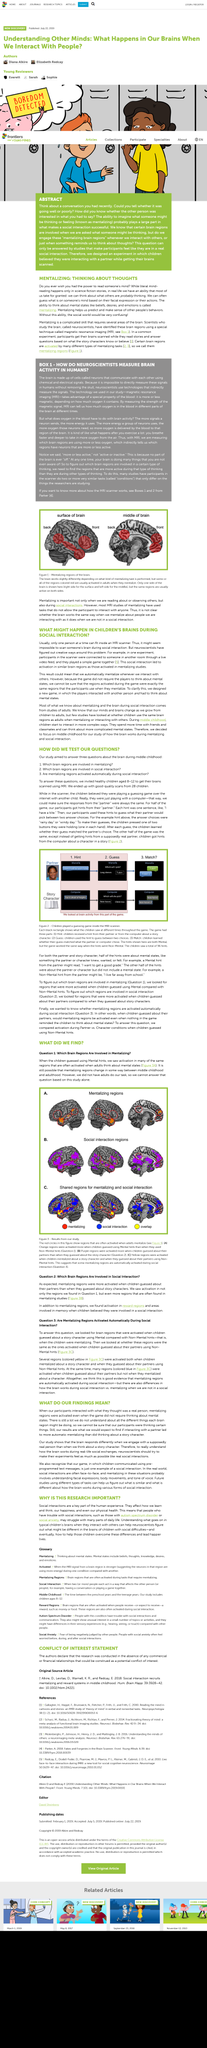List a handful of essential elements in this visual. After examining the brain scans of children while they played a guessing game, researchers found that the purple brain region was activated more when children guessed about their partners than when they guessed about the story character. The study utilized an MRI scanner to scan the brains of the children involved in the research. Exercising vigorously can cause a person to breathe faster and more deeply in order to obtain a sufficient supply of oxygen from the air. The fact that no adults participated in the task is self-evident. Magnetic Resonance Imaging, commonly referred to as MRI, is a non-invasive medical imaging technique that utilizes the principles of nuclear magnetic resonance to generate detailed images of internal body structures. 